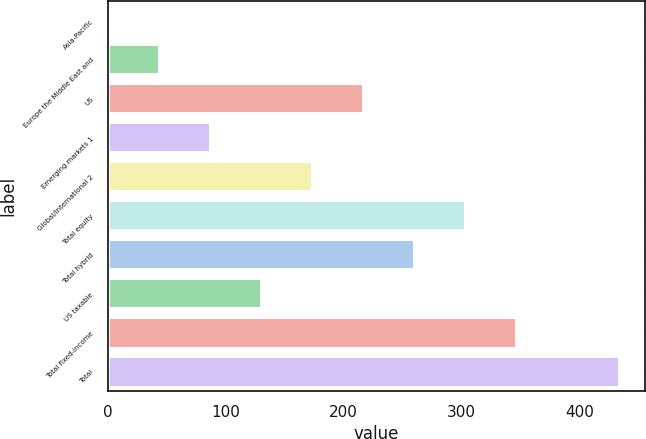<chart> <loc_0><loc_0><loc_500><loc_500><bar_chart><fcel>Asia-Pacific<fcel>Europe the Middle East and<fcel>US<fcel>Emerging markets 1<fcel>Global/international 2<fcel>Total equity<fcel>Total hybrid<fcel>US taxable<fcel>Total fixed-income<fcel>Total<nl><fcel>0.8<fcel>44.14<fcel>217.5<fcel>87.48<fcel>174.16<fcel>304.18<fcel>260.84<fcel>130.82<fcel>347.52<fcel>434.2<nl></chart> 